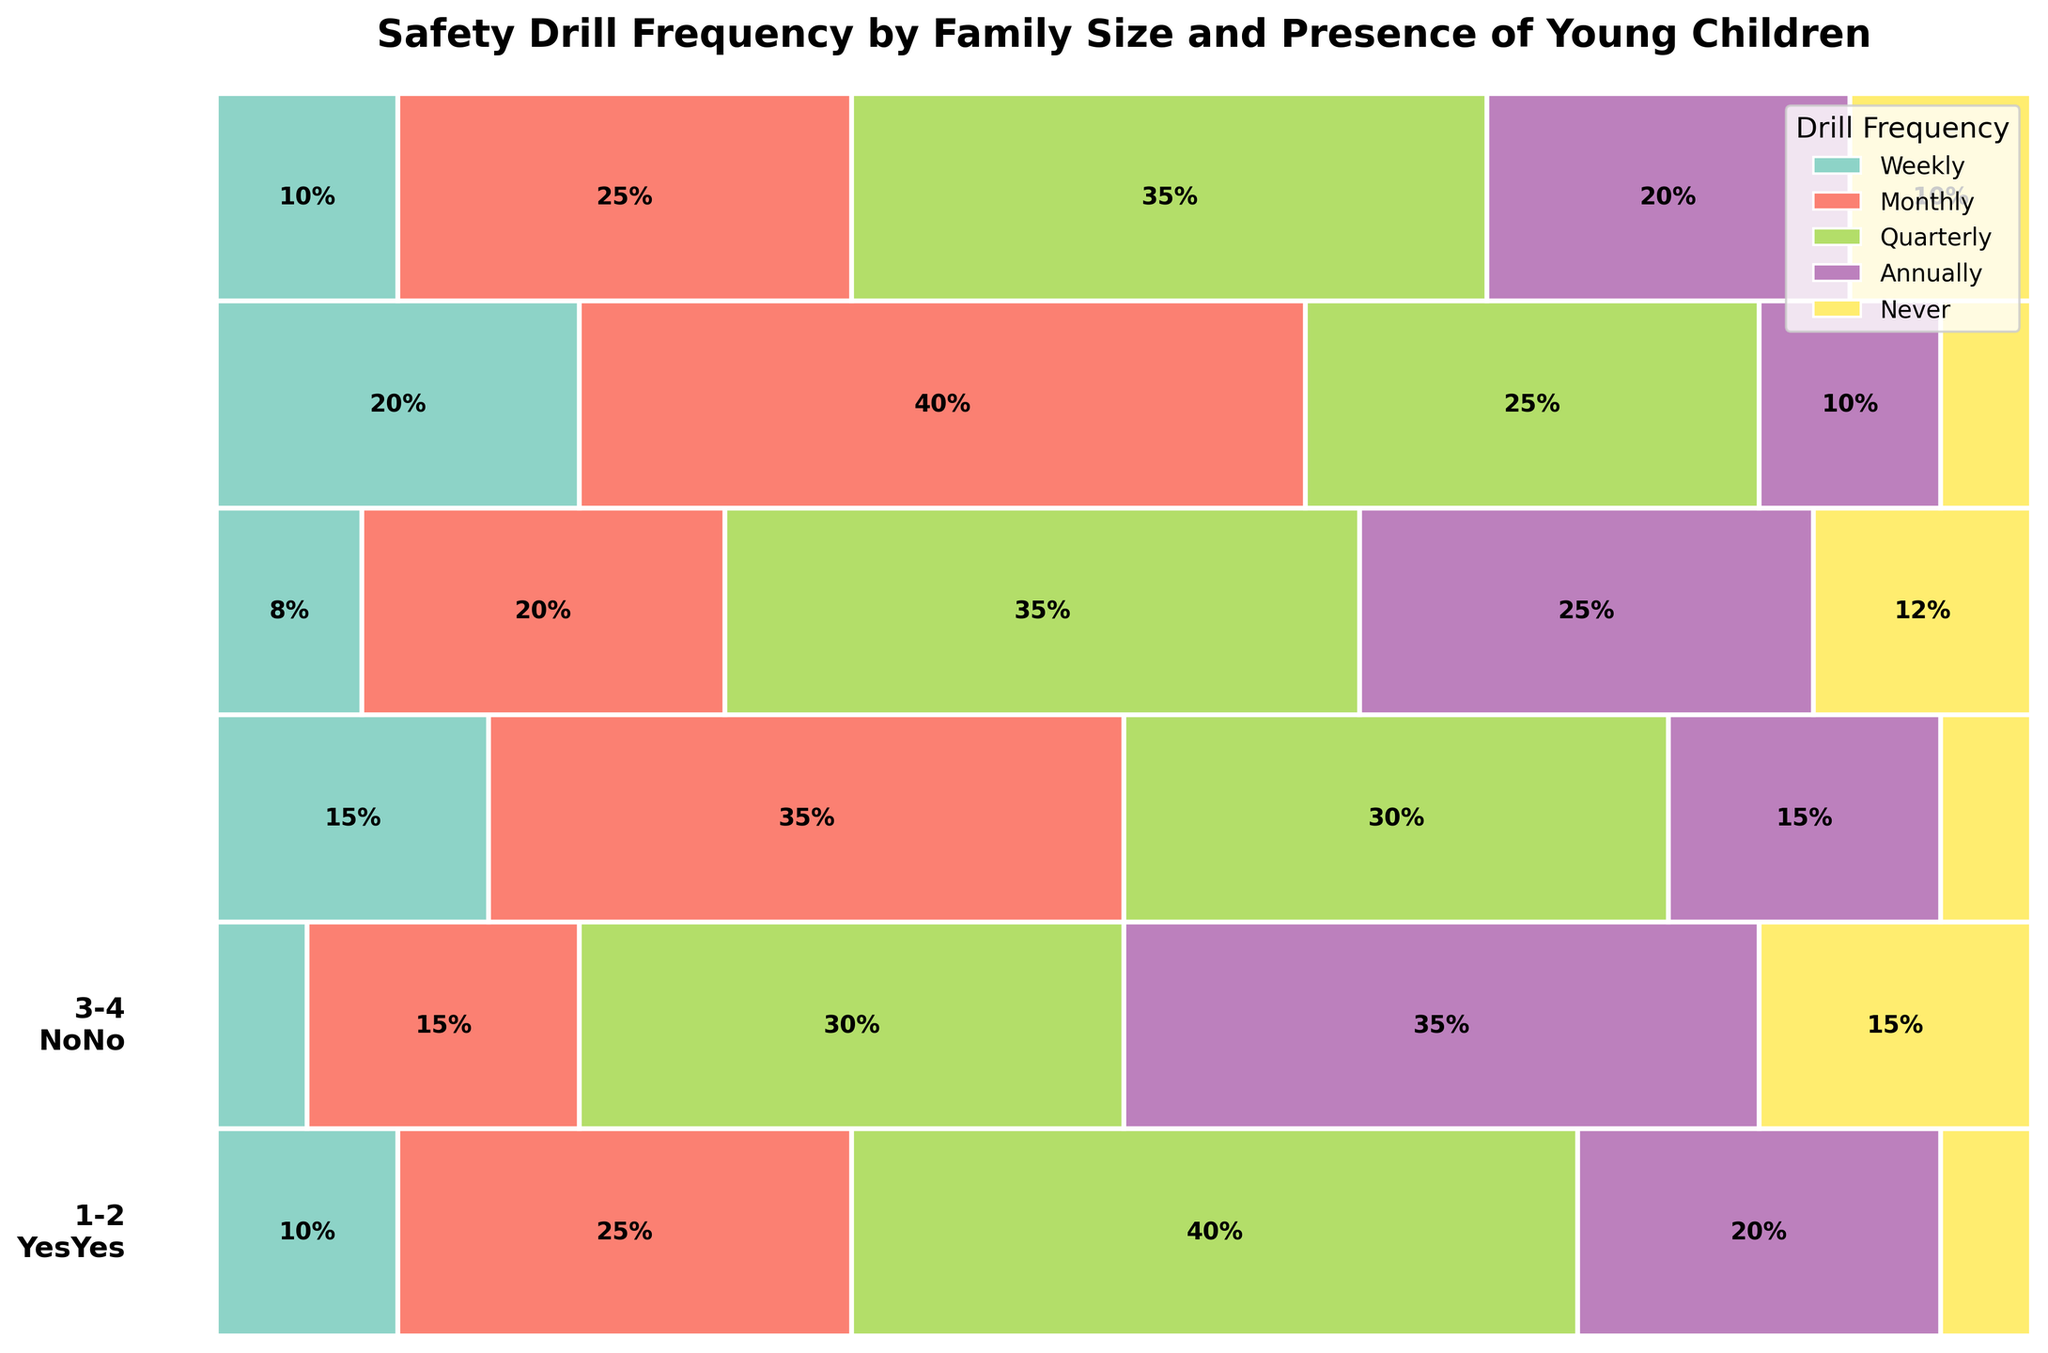What's the title of the figure? The title of the figure is typically located at the top and summarizes the data presented in the chart. In this case, the title is "Safety Drill Frequency by Family Size and Presence of Young Children".
Answer: Safety Drill Frequency by Family Size and Presence of Young Children How many frequency categories are there in the plot? By examining the legend or the different colored sections in the plot, we can count the unique frequency categories. There are five frequency categories shown in the legend.
Answer: Five Which family size with young children has the highest percentage of weekly drills? Looking at the different sections in the plot, identify the family size with young children. Compare the sizes of the weekly frequency sections visually. The family size 5+ with young children has the highest percentage of weekly drills.
Answer: 5+ What percentage of 3-4 member families without young children conduct safety drills monthly? Examine the section for 3-4 member families without young children and locate the monthly frequency category by its color from the legend. The text within that section indicates the percentage.
Answer: 20% Do more families with young children conduct safety drills quarterly compared to those without young children? Sum the percentages of families conducting safety drills on a quarterly basis within both categories (with and without young children) across all family sizes. Compare these sums to determine which is greater. With young children: (40 + 30 + 25) = 95%, Without young children: (30 + 35 + 35) = 100%.
Answer: No Which family size category has the least percentage of families conducting safety drills annually? Look at each family size category and find the annual frequency section to see which section is the smallest. 5+ member families with young children have the smallest section for annual frequency.
Answer: 5+ with young children Are there more families of size 1-2 with young children or without young children that never conduct safety drills? Compare the "Never" frequency sections for families of size 1-2 with and without young children. The "Never" section without young children is larger.
Answer: Without young children What is the most common frequency of safety drills among families of size 3-4 with young children? Identify the largest section within the 3-4 member families with young children and note the corresponding frequency category. The largest section is for the monthly frequency.
Answer: Monthly How does the frequency of weekly drills compare between families with young children and those without in the 5+ category? Compare the size of the weekly frequency section in the 5+ family size for both groups (with and without young children). The section for families with young children is larger than for those without.
Answer: Greater in families with young children Which frequency category has the least percentage representation overall? Sum the percentages of each frequency category across all family sizes and both child presence groups to see which has the smallest total. The "Never" category totals to (5+15+5+12+5+10) = 52%.
Answer: Never 